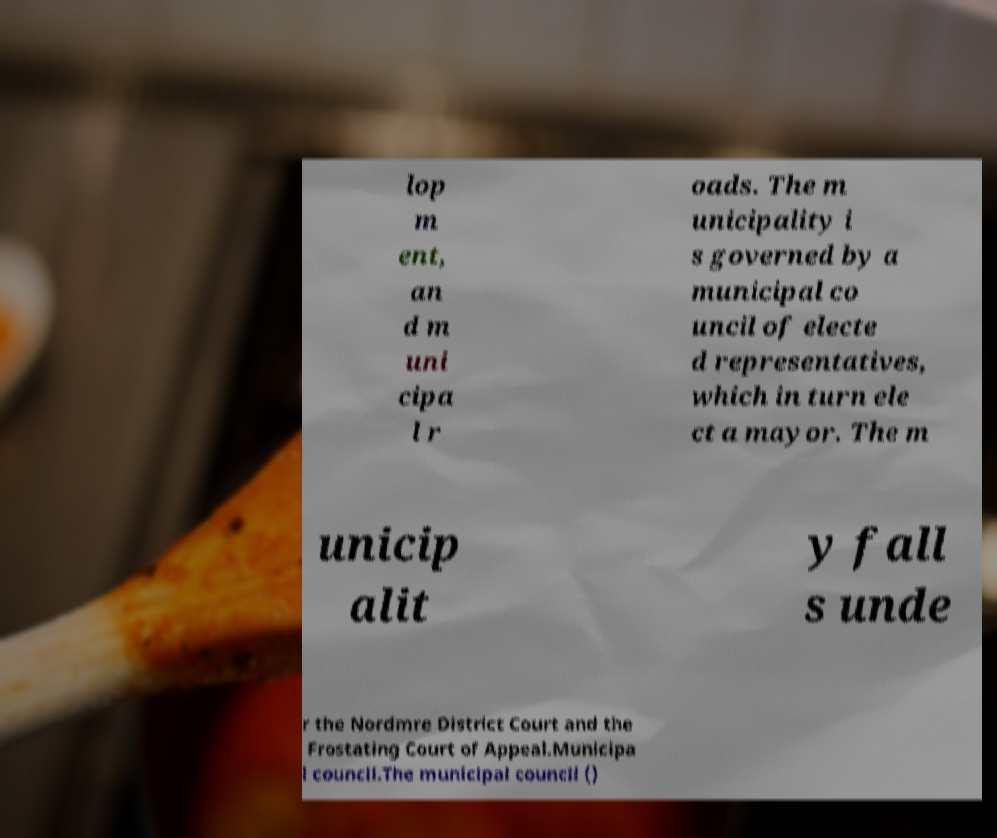For documentation purposes, I need the text within this image transcribed. Could you provide that? lop m ent, an d m uni cipa l r oads. The m unicipality i s governed by a municipal co uncil of electe d representatives, which in turn ele ct a mayor. The m unicip alit y fall s unde r the Nordmre District Court and the Frostating Court of Appeal.Municipa l council.The municipal council () 